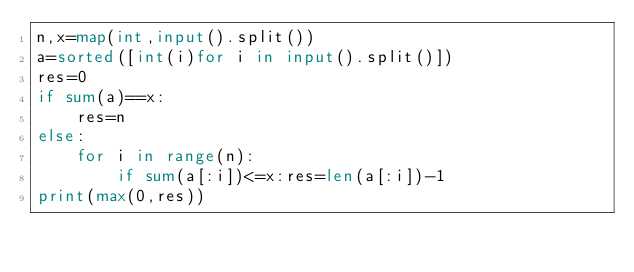Convert code to text. <code><loc_0><loc_0><loc_500><loc_500><_Python_>n,x=map(int,input().split())
a=sorted([int(i)for i in input().split()])
res=0
if sum(a)==x:
    res=n
else:
    for i in range(n):
        if sum(a[:i])<=x:res=len(a[:i])-1
print(max(0,res))</code> 